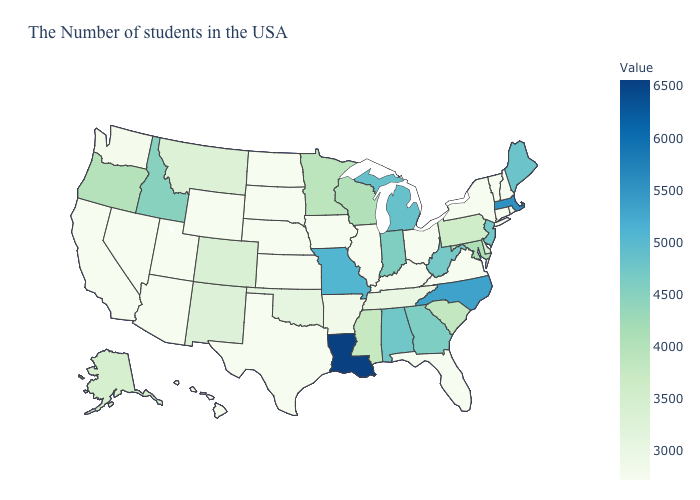Does the map have missing data?
Answer briefly. No. Does Michigan have a lower value than Louisiana?
Keep it brief. Yes. Does Massachusetts have the lowest value in the USA?
Concise answer only. No. 